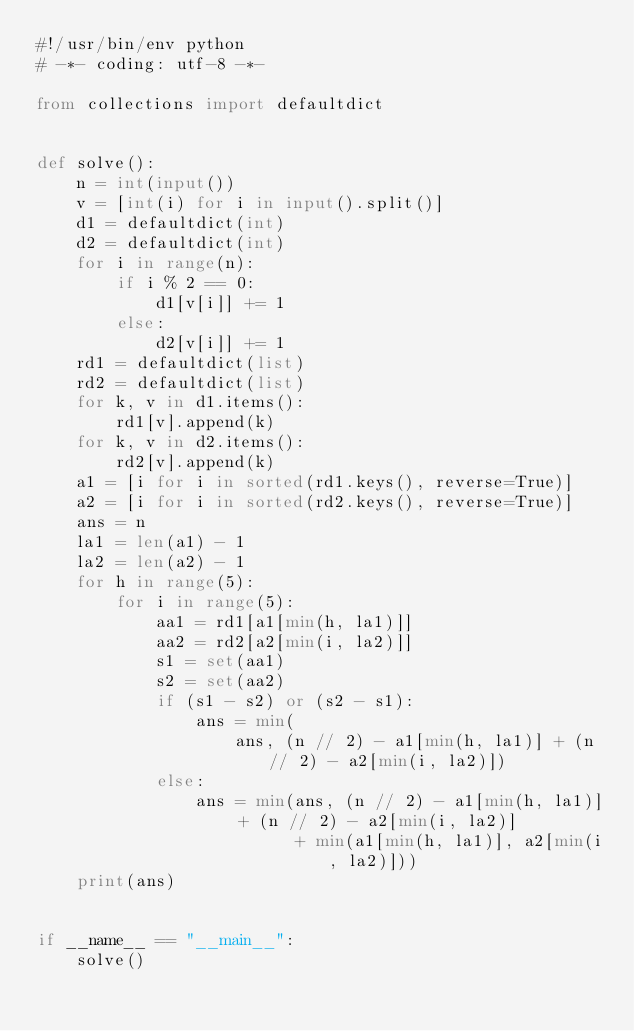Convert code to text. <code><loc_0><loc_0><loc_500><loc_500><_Python_>#!/usr/bin/env python
# -*- coding: utf-8 -*-

from collections import defaultdict


def solve():
    n = int(input())
    v = [int(i) for i in input().split()]
    d1 = defaultdict(int)
    d2 = defaultdict(int)
    for i in range(n):
        if i % 2 == 0:
            d1[v[i]] += 1
        else:
            d2[v[i]] += 1
    rd1 = defaultdict(list)
    rd2 = defaultdict(list)
    for k, v in d1.items():
        rd1[v].append(k)
    for k, v in d2.items():
        rd2[v].append(k)
    a1 = [i for i in sorted(rd1.keys(), reverse=True)]
    a2 = [i for i in sorted(rd2.keys(), reverse=True)]
    ans = n
    la1 = len(a1) - 1
    la2 = len(a2) - 1
    for h in range(5):
        for i in range(5):
            aa1 = rd1[a1[min(h, la1)]]
            aa2 = rd2[a2[min(i, la2)]]
            s1 = set(aa1)
            s2 = set(aa2)
            if (s1 - s2) or (s2 - s1):
                ans = min(
                    ans, (n // 2) - a1[min(h, la1)] + (n // 2) - a2[min(i, la2)])
            else:
                ans = min(ans, (n // 2) - a1[min(h, la1)] + (n // 2) - a2[min(i, la2)]
                          + min(a1[min(h, la1)], a2[min(i, la2)]))
    print(ans)


if __name__ == "__main__":
    solve()
</code> 